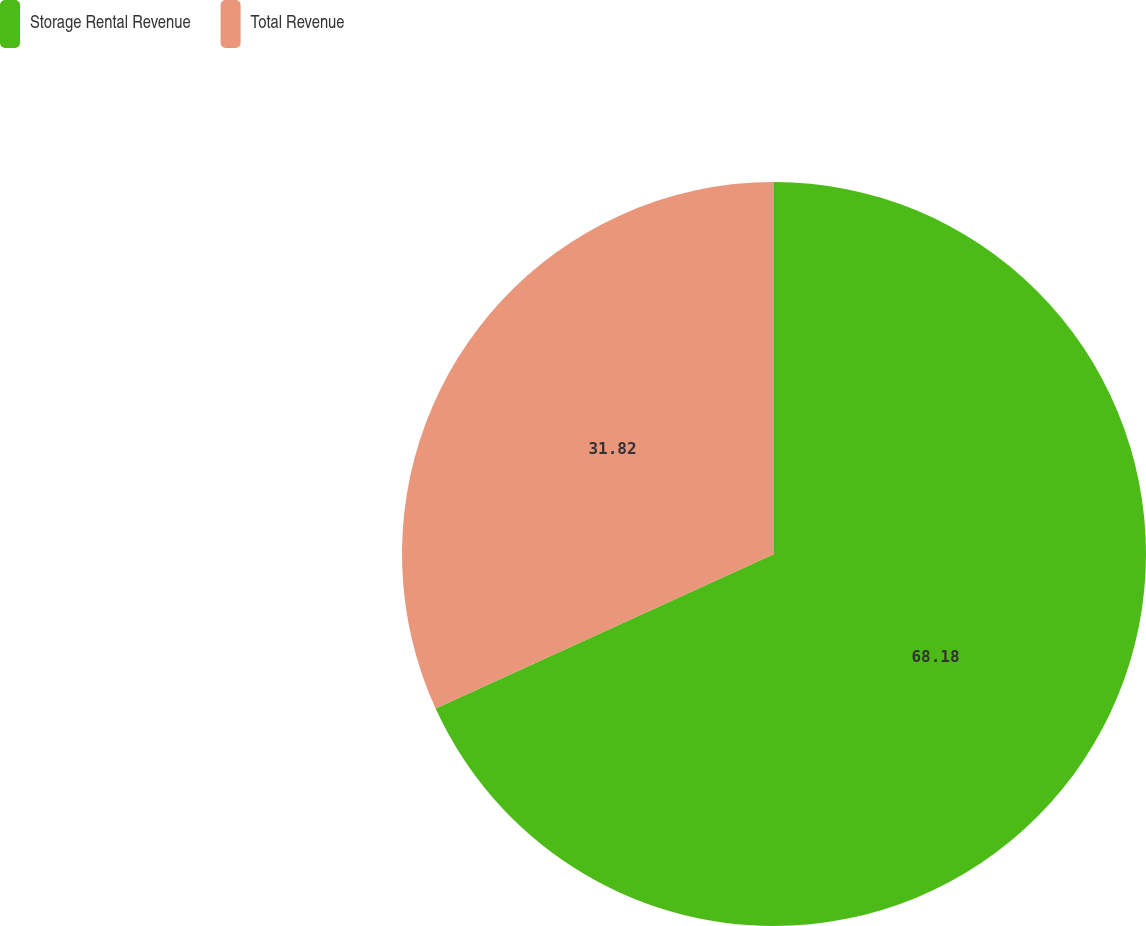Convert chart to OTSL. <chart><loc_0><loc_0><loc_500><loc_500><pie_chart><fcel>Storage Rental Revenue<fcel>Total Revenue<nl><fcel>68.18%<fcel>31.82%<nl></chart> 